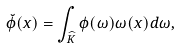Convert formula to latex. <formula><loc_0><loc_0><loc_500><loc_500>\breve { \phi } ( x ) = \int _ { \widehat { K } } \phi ( \omega ) \omega ( x ) d \omega ,</formula> 